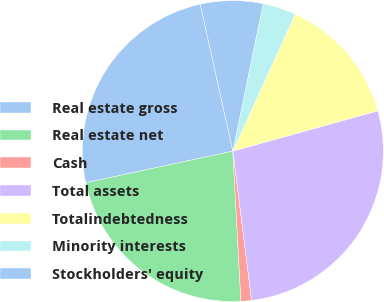<chart> <loc_0><loc_0><loc_500><loc_500><pie_chart><fcel>Real estate gross<fcel>Real estate net<fcel>Cash<fcel>Total assets<fcel>Totalindebtedness<fcel>Minority interests<fcel>Stockholders' equity<nl><fcel>24.9%<fcel>22.48%<fcel>1.14%<fcel>27.32%<fcel>13.89%<fcel>3.57%<fcel>6.7%<nl></chart> 